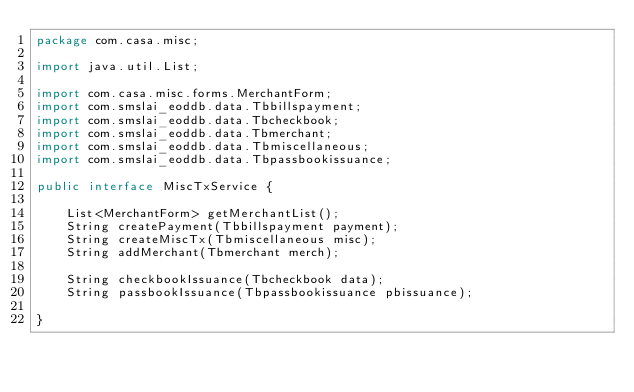<code> <loc_0><loc_0><loc_500><loc_500><_Java_>package com.casa.misc;

import java.util.List;

import com.casa.misc.forms.MerchantForm;
import com.smslai_eoddb.data.Tbbillspayment;
import com.smslai_eoddb.data.Tbcheckbook;
import com.smslai_eoddb.data.Tbmerchant;
import com.smslai_eoddb.data.Tbmiscellaneous;
import com.smslai_eoddb.data.Tbpassbookissuance;

public interface MiscTxService {
	
	List<MerchantForm> getMerchantList();
	String createPayment(Tbbillspayment payment);
	String createMiscTx(Tbmiscellaneous misc);
	String addMerchant(Tbmerchant merch);
	
	String checkbookIssuance(Tbcheckbook data);
	String passbookIssuance(Tbpassbookissuance pbissuance);

}
</code> 